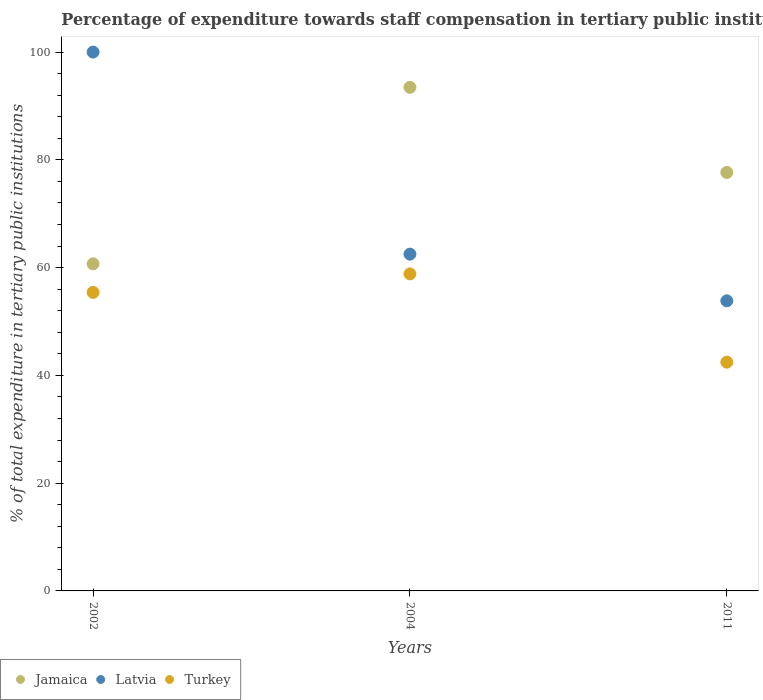How many different coloured dotlines are there?
Provide a succinct answer. 3. What is the percentage of expenditure towards staff compensation in Jamaica in 2002?
Give a very brief answer. 60.7. Across all years, what is the maximum percentage of expenditure towards staff compensation in Jamaica?
Your response must be concise. 93.46. Across all years, what is the minimum percentage of expenditure towards staff compensation in Latvia?
Provide a succinct answer. 53.84. In which year was the percentage of expenditure towards staff compensation in Turkey maximum?
Provide a succinct answer. 2004. In which year was the percentage of expenditure towards staff compensation in Turkey minimum?
Make the answer very short. 2011. What is the total percentage of expenditure towards staff compensation in Jamaica in the graph?
Your response must be concise. 231.82. What is the difference between the percentage of expenditure towards staff compensation in Turkey in 2004 and that in 2011?
Provide a succinct answer. 16.38. What is the difference between the percentage of expenditure towards staff compensation in Turkey in 2011 and the percentage of expenditure towards staff compensation in Latvia in 2002?
Offer a terse response. -57.55. What is the average percentage of expenditure towards staff compensation in Jamaica per year?
Give a very brief answer. 77.27. In the year 2004, what is the difference between the percentage of expenditure towards staff compensation in Jamaica and percentage of expenditure towards staff compensation in Latvia?
Make the answer very short. 30.96. In how many years, is the percentage of expenditure towards staff compensation in Turkey greater than 20 %?
Provide a succinct answer. 3. What is the ratio of the percentage of expenditure towards staff compensation in Latvia in 2002 to that in 2011?
Give a very brief answer. 1.86. What is the difference between the highest and the second highest percentage of expenditure towards staff compensation in Turkey?
Give a very brief answer. 3.43. What is the difference between the highest and the lowest percentage of expenditure towards staff compensation in Turkey?
Provide a short and direct response. 16.38. Is the percentage of expenditure towards staff compensation in Turkey strictly greater than the percentage of expenditure towards staff compensation in Latvia over the years?
Offer a terse response. No. Is the percentage of expenditure towards staff compensation in Jamaica strictly less than the percentage of expenditure towards staff compensation in Latvia over the years?
Offer a terse response. No. How many years are there in the graph?
Make the answer very short. 3. Are the values on the major ticks of Y-axis written in scientific E-notation?
Give a very brief answer. No. Does the graph contain any zero values?
Make the answer very short. No. Does the graph contain grids?
Offer a very short reply. No. How are the legend labels stacked?
Provide a succinct answer. Horizontal. What is the title of the graph?
Your answer should be very brief. Percentage of expenditure towards staff compensation in tertiary public institutions. What is the label or title of the X-axis?
Offer a terse response. Years. What is the label or title of the Y-axis?
Provide a succinct answer. % of total expenditure in tertiary public institutions. What is the % of total expenditure in tertiary public institutions in Jamaica in 2002?
Provide a succinct answer. 60.7. What is the % of total expenditure in tertiary public institutions in Turkey in 2002?
Ensure brevity in your answer.  55.41. What is the % of total expenditure in tertiary public institutions in Jamaica in 2004?
Ensure brevity in your answer.  93.46. What is the % of total expenditure in tertiary public institutions of Latvia in 2004?
Provide a succinct answer. 62.5. What is the % of total expenditure in tertiary public institutions of Turkey in 2004?
Keep it short and to the point. 58.84. What is the % of total expenditure in tertiary public institutions of Jamaica in 2011?
Provide a succinct answer. 77.66. What is the % of total expenditure in tertiary public institutions of Latvia in 2011?
Make the answer very short. 53.84. What is the % of total expenditure in tertiary public institutions in Turkey in 2011?
Your answer should be very brief. 42.45. Across all years, what is the maximum % of total expenditure in tertiary public institutions in Jamaica?
Your response must be concise. 93.46. Across all years, what is the maximum % of total expenditure in tertiary public institutions of Turkey?
Give a very brief answer. 58.84. Across all years, what is the minimum % of total expenditure in tertiary public institutions in Jamaica?
Your answer should be compact. 60.7. Across all years, what is the minimum % of total expenditure in tertiary public institutions of Latvia?
Give a very brief answer. 53.84. Across all years, what is the minimum % of total expenditure in tertiary public institutions of Turkey?
Make the answer very short. 42.45. What is the total % of total expenditure in tertiary public institutions in Jamaica in the graph?
Ensure brevity in your answer.  231.82. What is the total % of total expenditure in tertiary public institutions in Latvia in the graph?
Offer a terse response. 216.34. What is the total % of total expenditure in tertiary public institutions in Turkey in the graph?
Give a very brief answer. 156.7. What is the difference between the % of total expenditure in tertiary public institutions of Jamaica in 2002 and that in 2004?
Offer a terse response. -32.75. What is the difference between the % of total expenditure in tertiary public institutions in Latvia in 2002 and that in 2004?
Offer a terse response. 37.5. What is the difference between the % of total expenditure in tertiary public institutions of Turkey in 2002 and that in 2004?
Give a very brief answer. -3.43. What is the difference between the % of total expenditure in tertiary public institutions of Jamaica in 2002 and that in 2011?
Provide a short and direct response. -16.96. What is the difference between the % of total expenditure in tertiary public institutions in Latvia in 2002 and that in 2011?
Offer a very short reply. 46.16. What is the difference between the % of total expenditure in tertiary public institutions of Turkey in 2002 and that in 2011?
Give a very brief answer. 12.95. What is the difference between the % of total expenditure in tertiary public institutions in Jamaica in 2004 and that in 2011?
Offer a terse response. 15.79. What is the difference between the % of total expenditure in tertiary public institutions in Latvia in 2004 and that in 2011?
Your answer should be very brief. 8.66. What is the difference between the % of total expenditure in tertiary public institutions in Turkey in 2004 and that in 2011?
Offer a very short reply. 16.38. What is the difference between the % of total expenditure in tertiary public institutions in Jamaica in 2002 and the % of total expenditure in tertiary public institutions in Latvia in 2004?
Make the answer very short. -1.8. What is the difference between the % of total expenditure in tertiary public institutions of Jamaica in 2002 and the % of total expenditure in tertiary public institutions of Turkey in 2004?
Keep it short and to the point. 1.87. What is the difference between the % of total expenditure in tertiary public institutions of Latvia in 2002 and the % of total expenditure in tertiary public institutions of Turkey in 2004?
Your answer should be compact. 41.16. What is the difference between the % of total expenditure in tertiary public institutions of Jamaica in 2002 and the % of total expenditure in tertiary public institutions of Latvia in 2011?
Offer a very short reply. 6.86. What is the difference between the % of total expenditure in tertiary public institutions in Jamaica in 2002 and the % of total expenditure in tertiary public institutions in Turkey in 2011?
Give a very brief answer. 18.25. What is the difference between the % of total expenditure in tertiary public institutions in Latvia in 2002 and the % of total expenditure in tertiary public institutions in Turkey in 2011?
Make the answer very short. 57.55. What is the difference between the % of total expenditure in tertiary public institutions of Jamaica in 2004 and the % of total expenditure in tertiary public institutions of Latvia in 2011?
Offer a very short reply. 39.62. What is the difference between the % of total expenditure in tertiary public institutions of Jamaica in 2004 and the % of total expenditure in tertiary public institutions of Turkey in 2011?
Offer a terse response. 51. What is the difference between the % of total expenditure in tertiary public institutions of Latvia in 2004 and the % of total expenditure in tertiary public institutions of Turkey in 2011?
Keep it short and to the point. 20.05. What is the average % of total expenditure in tertiary public institutions in Jamaica per year?
Your answer should be compact. 77.27. What is the average % of total expenditure in tertiary public institutions of Latvia per year?
Provide a short and direct response. 72.11. What is the average % of total expenditure in tertiary public institutions of Turkey per year?
Make the answer very short. 52.23. In the year 2002, what is the difference between the % of total expenditure in tertiary public institutions of Jamaica and % of total expenditure in tertiary public institutions of Latvia?
Your response must be concise. -39.3. In the year 2002, what is the difference between the % of total expenditure in tertiary public institutions of Jamaica and % of total expenditure in tertiary public institutions of Turkey?
Your answer should be very brief. 5.29. In the year 2002, what is the difference between the % of total expenditure in tertiary public institutions of Latvia and % of total expenditure in tertiary public institutions of Turkey?
Give a very brief answer. 44.59. In the year 2004, what is the difference between the % of total expenditure in tertiary public institutions in Jamaica and % of total expenditure in tertiary public institutions in Latvia?
Provide a short and direct response. 30.96. In the year 2004, what is the difference between the % of total expenditure in tertiary public institutions of Jamaica and % of total expenditure in tertiary public institutions of Turkey?
Your response must be concise. 34.62. In the year 2004, what is the difference between the % of total expenditure in tertiary public institutions of Latvia and % of total expenditure in tertiary public institutions of Turkey?
Give a very brief answer. 3.66. In the year 2011, what is the difference between the % of total expenditure in tertiary public institutions in Jamaica and % of total expenditure in tertiary public institutions in Latvia?
Offer a very short reply. 23.83. In the year 2011, what is the difference between the % of total expenditure in tertiary public institutions in Jamaica and % of total expenditure in tertiary public institutions in Turkey?
Your answer should be compact. 35.21. In the year 2011, what is the difference between the % of total expenditure in tertiary public institutions of Latvia and % of total expenditure in tertiary public institutions of Turkey?
Your answer should be very brief. 11.38. What is the ratio of the % of total expenditure in tertiary public institutions in Jamaica in 2002 to that in 2004?
Provide a succinct answer. 0.65. What is the ratio of the % of total expenditure in tertiary public institutions in Latvia in 2002 to that in 2004?
Your answer should be compact. 1.6. What is the ratio of the % of total expenditure in tertiary public institutions of Turkey in 2002 to that in 2004?
Give a very brief answer. 0.94. What is the ratio of the % of total expenditure in tertiary public institutions in Jamaica in 2002 to that in 2011?
Keep it short and to the point. 0.78. What is the ratio of the % of total expenditure in tertiary public institutions in Latvia in 2002 to that in 2011?
Offer a very short reply. 1.86. What is the ratio of the % of total expenditure in tertiary public institutions in Turkey in 2002 to that in 2011?
Give a very brief answer. 1.31. What is the ratio of the % of total expenditure in tertiary public institutions of Jamaica in 2004 to that in 2011?
Your answer should be compact. 1.2. What is the ratio of the % of total expenditure in tertiary public institutions of Latvia in 2004 to that in 2011?
Your answer should be compact. 1.16. What is the ratio of the % of total expenditure in tertiary public institutions of Turkey in 2004 to that in 2011?
Your response must be concise. 1.39. What is the difference between the highest and the second highest % of total expenditure in tertiary public institutions in Jamaica?
Give a very brief answer. 15.79. What is the difference between the highest and the second highest % of total expenditure in tertiary public institutions in Latvia?
Keep it short and to the point. 37.5. What is the difference between the highest and the second highest % of total expenditure in tertiary public institutions in Turkey?
Your response must be concise. 3.43. What is the difference between the highest and the lowest % of total expenditure in tertiary public institutions of Jamaica?
Make the answer very short. 32.75. What is the difference between the highest and the lowest % of total expenditure in tertiary public institutions in Latvia?
Your answer should be very brief. 46.16. What is the difference between the highest and the lowest % of total expenditure in tertiary public institutions of Turkey?
Offer a very short reply. 16.38. 